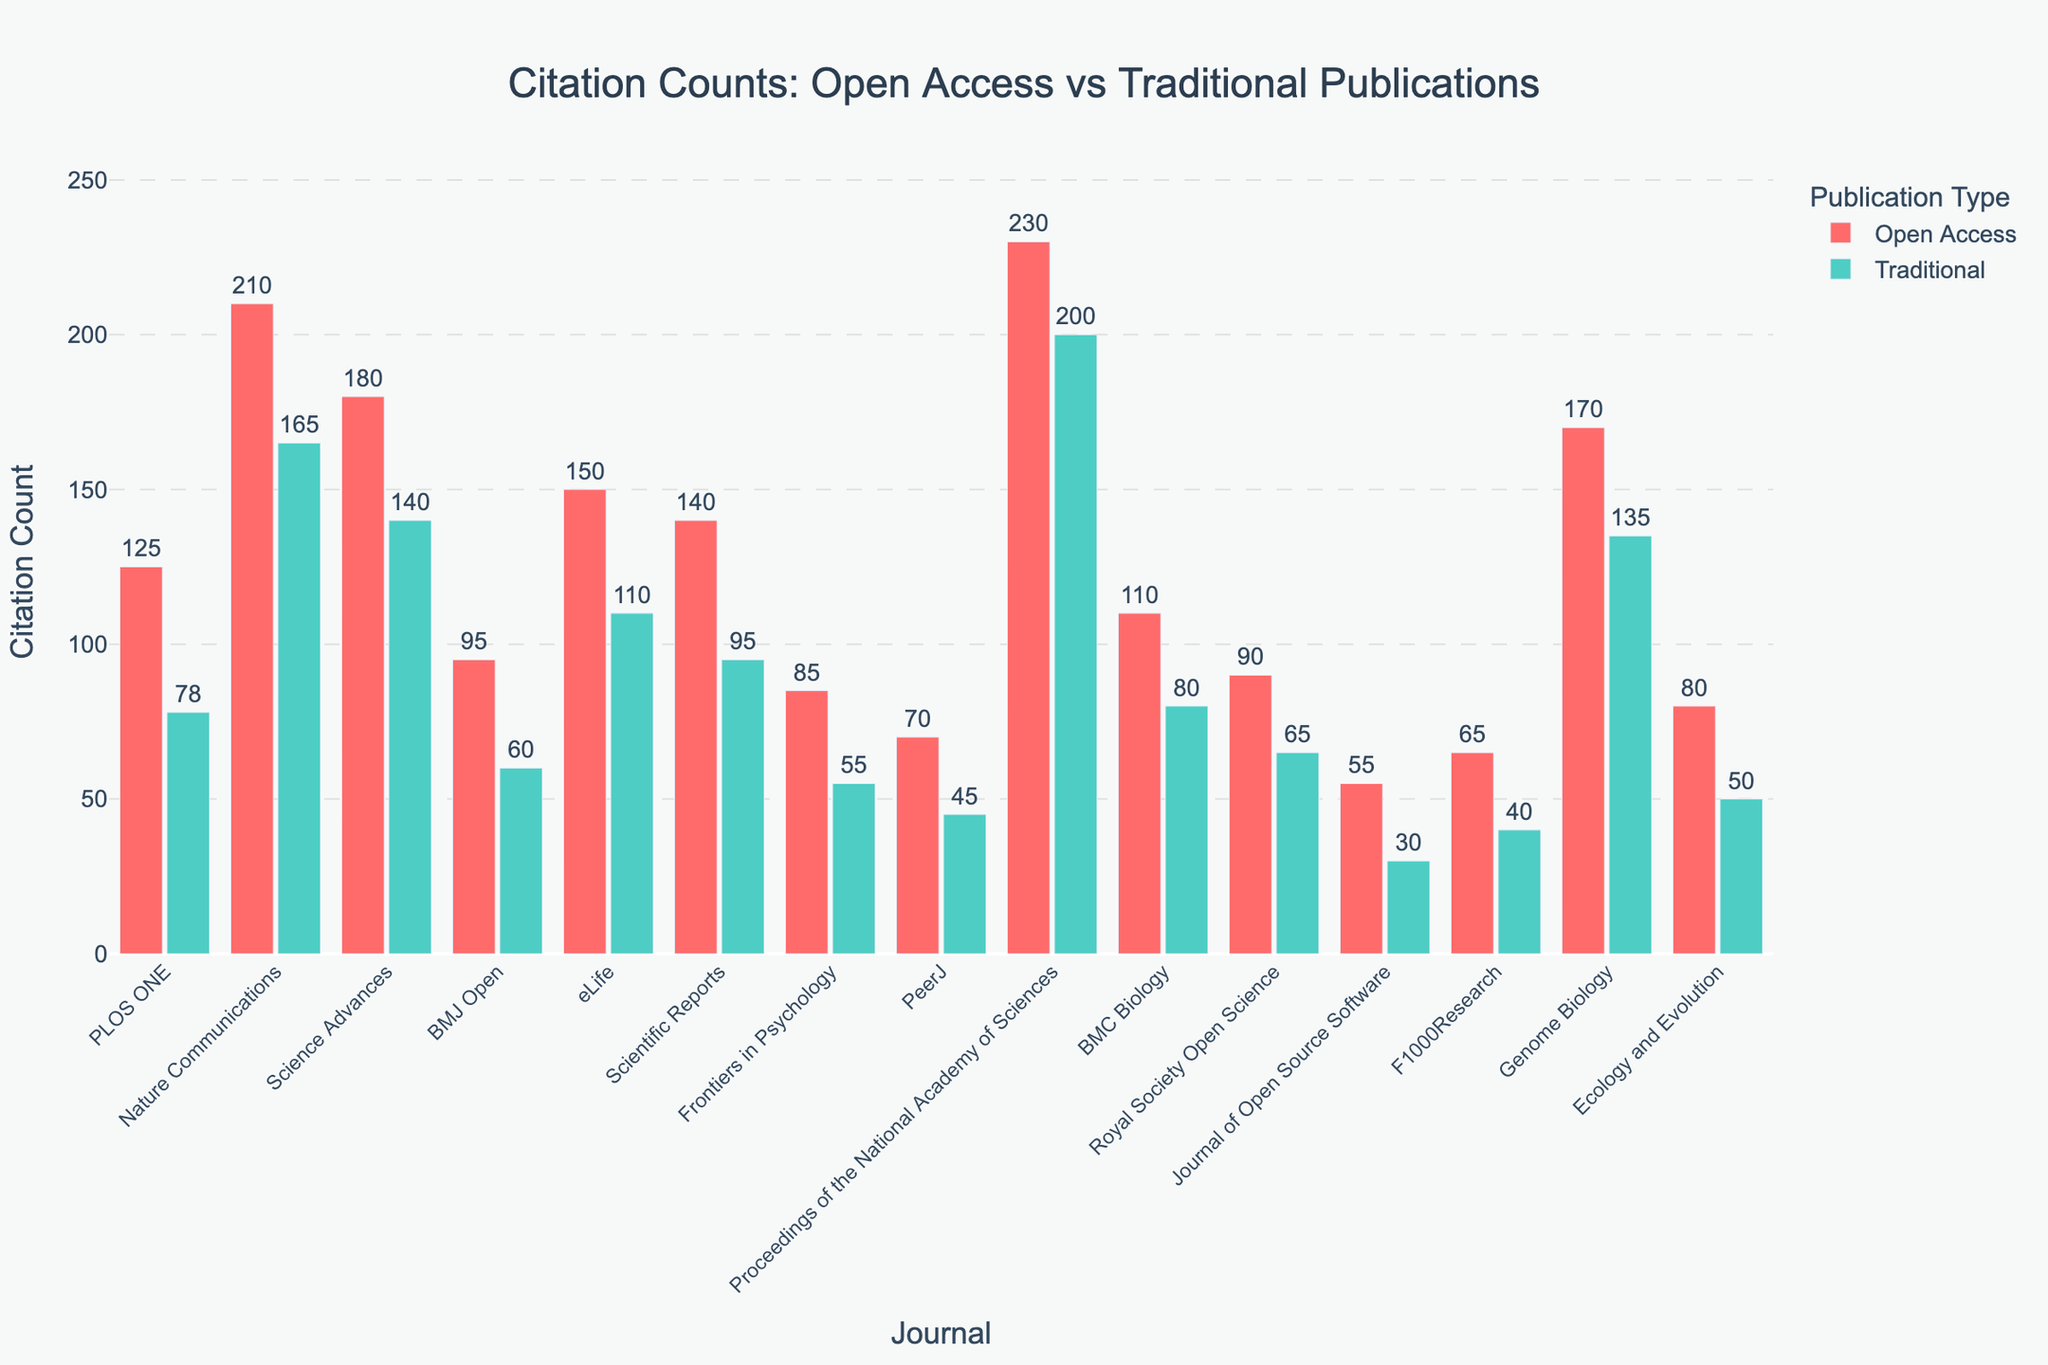Which journal has the highest citation count for open access publications? Referring to the figure, each bar representing open access citations is color-coded in red. The bar for "Proceedings of the National Academy of Sciences" is the tallest among the open access publication bars with 230 citations.
Answer: Proceedings of the National Academy of Sciences What is the difference in citation counts between open access and traditional publications for the journal "Nature Communications"? From the figure, the red bar for open access citations shows 210 citations, and the green bar for traditional citations shows 165 citations. The difference is 210 - 165 = 45 citations.
Answer: 45 Which journal shows the smallest difference in citation counts between open access and traditional publications? By examining the height differences of the bars representing open access and traditional citations for each journal, "PeerJ" has the smallest difference. The figures are 70 (open access) and 45 (traditional), resulting in a difference of 25 citations.
Answer: PeerJ How many journals have more citations in open access publications than traditional ones? Counting the instances where the red bar (open access citations) is taller than the green bar (traditional citations) reveals that PLOS ONE, Nature Communications, Science Advances, BMJ Open, eLife, Scientific Reports, Frontiers in Psychology, Royal Society Open Science, Journal of Open Source Software, F1000Research, and Ecology and Evolution fit this criterion, amounting to 11 journals.
Answer: 11 What is the average citation count for traditional publications across all journals? Adding up all the traditional citation counts (78 + 165 + 140 + 60 + 110 + 95 + 55 + 45 + 200 + 80 + 65 + 30 + 40 + 135 + 50) gives 1,348. There are 15 journals, so the average is 1,348 / 15 = 89.87 citations.
Answer: 89.87 Which journal has the least number of open access citations? From the figure, the journal with the shortest red bar (open access citations) is "Journal of Open Source Software," which has 55 citations.
Answer: Journal of Open Source Software For "Genome Biology," what is the sum of its open access and traditional citation counts? Referring to the figure, "Genome Biology" has 170 citation counts for open access and 135 for traditional. The sum is 170 + 135 = 305.
Answer: 305 Which journal has the highest citation count for traditional publications? Observing the tallest green bar in the figure, "Proceedings of the National Academy of Sciences" has the highest traditional citation count with 200 citations.
Answer: Proceedings of the National Academy of Sciences 